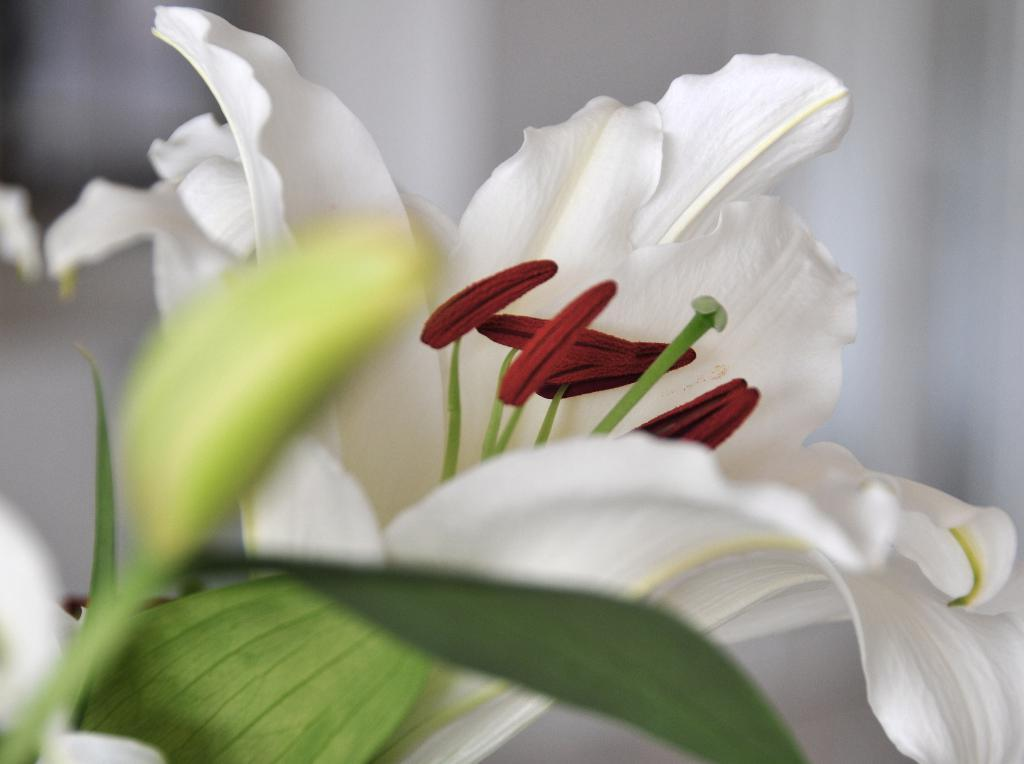What type of plant life can be seen in the image? There are leaves and flowers in the image. Can you describe the background of the image? The background of the image is blurry. What type of joke is being told by the flowers in the image? There are no jokes being told in the image; it features leaves and flowers in a natural setting. 